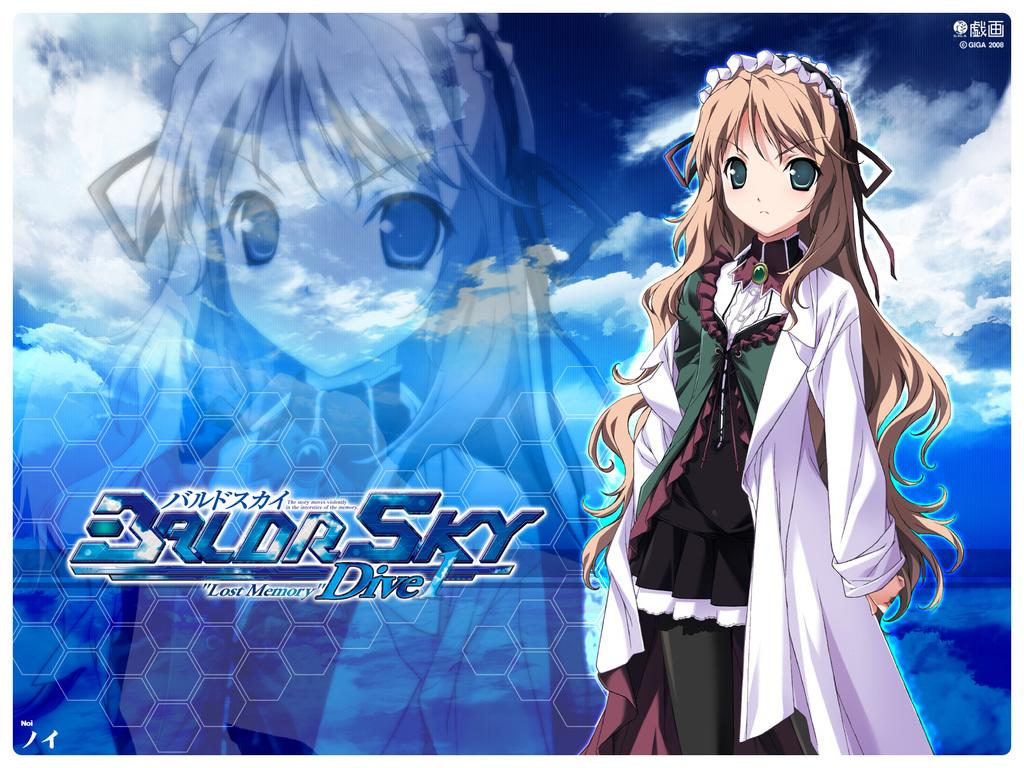What type of image is being described? The image is animated. Where is the woman located in the image? The woman is standing on the right side of the image. What can be found on the left side of the image? There is some text on the left side of the image. Can you describe the woman behind the text? There is a woman behind the text. What can be seen in the background of the image? The background of the image includes sky with clouds. What type of icicle can be seen hanging from the woman's hair in the image? There is no icicle present in the image; it is an animated image with no ice or frozen elements. What type of desk is visible in the image? There is no desk present in the image; the focus is on the women and the text. 